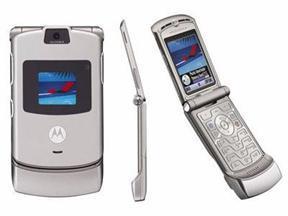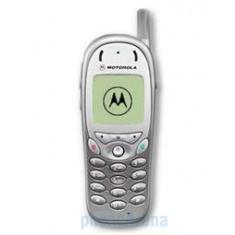The first image is the image on the left, the second image is the image on the right. Examine the images to the left and right. Is the description "The left image features a phone style that does not flip up and has a short antenna on the top and a rectangular display on the front, and the right image includes a phone with its lid flipped up." accurate? Answer yes or no. No. The first image is the image on the left, the second image is the image on the right. Evaluate the accuracy of this statement regarding the images: "A flip phone is in the open position in the image on the right.". Is it true? Answer yes or no. No. 